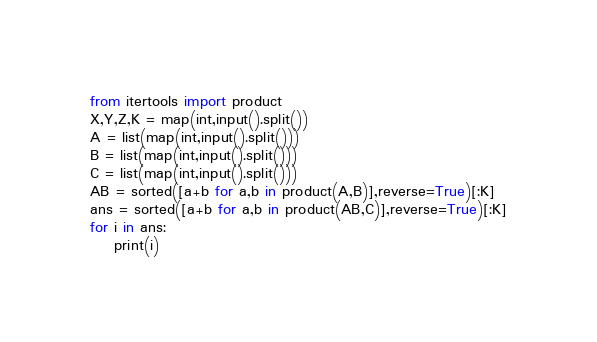<code> <loc_0><loc_0><loc_500><loc_500><_Python_>from itertools import product
X,Y,Z,K = map(int,input().split())
A = list(map(int,input().split()))
B = list(map(int,input().split()))
C = list(map(int,input().split()))
AB = sorted([a+b for a,b in product(A,B)],reverse=True)[:K]
ans = sorted([a+b for a,b in product(AB,C)],reverse=True)[:K]
for i in ans:
    print(i)</code> 